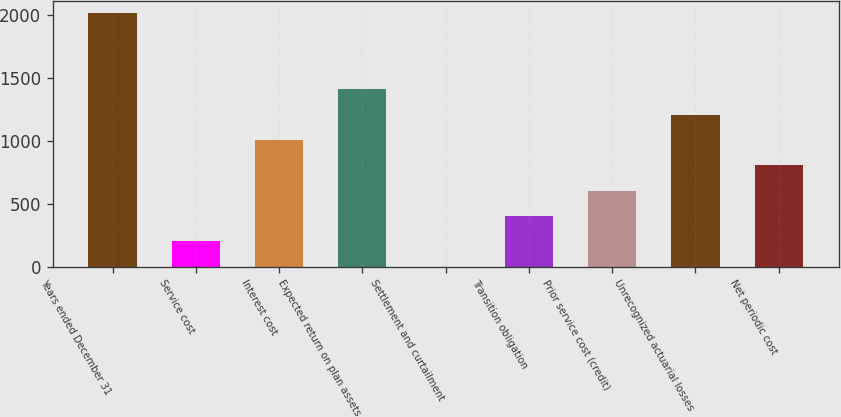Convert chart. <chart><loc_0><loc_0><loc_500><loc_500><bar_chart><fcel>Years ended December 31<fcel>Service cost<fcel>Interest cost<fcel>Expected return on plan assets<fcel>Settlement and curtailment<fcel>Transition obligation<fcel>Prior service cost (credit)<fcel>Unrecognized actuarial losses<fcel>Net periodic cost<nl><fcel>2012<fcel>201.38<fcel>1006.1<fcel>1408.46<fcel>0.2<fcel>402.56<fcel>603.74<fcel>1207.28<fcel>804.92<nl></chart> 